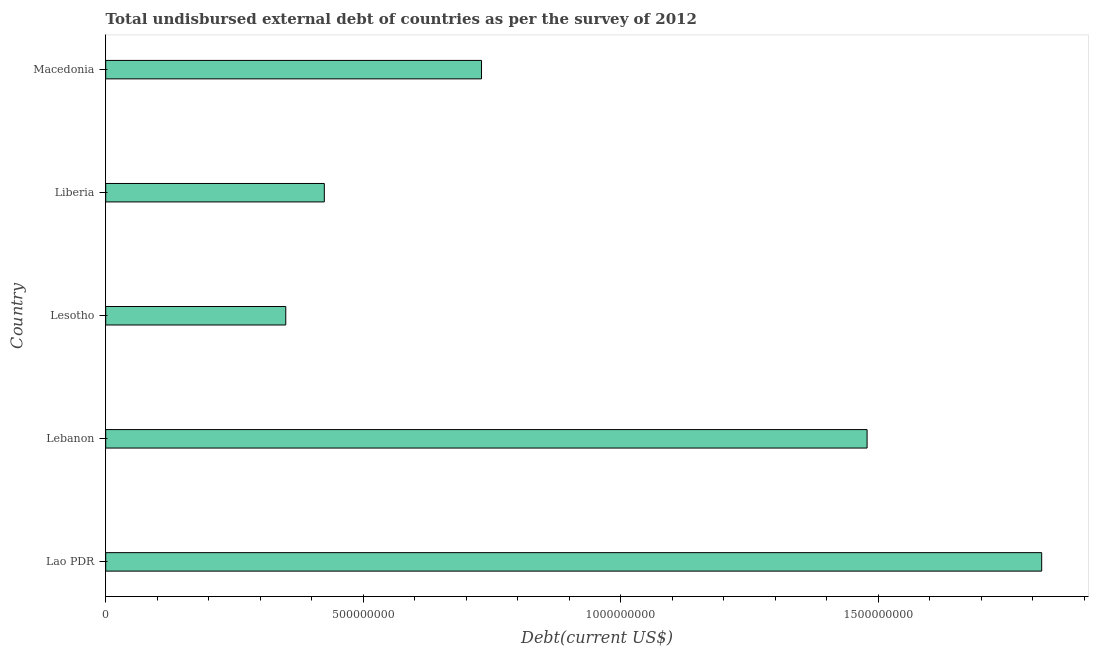Does the graph contain any zero values?
Your response must be concise. No. What is the title of the graph?
Make the answer very short. Total undisbursed external debt of countries as per the survey of 2012. What is the label or title of the X-axis?
Give a very brief answer. Debt(current US$). What is the total debt in Macedonia?
Ensure brevity in your answer.  7.30e+08. Across all countries, what is the maximum total debt?
Offer a very short reply. 1.82e+09. Across all countries, what is the minimum total debt?
Keep it short and to the point. 3.50e+08. In which country was the total debt maximum?
Ensure brevity in your answer.  Lao PDR. In which country was the total debt minimum?
Your response must be concise. Lesotho. What is the sum of the total debt?
Offer a very short reply. 4.80e+09. What is the difference between the total debt in Lebanon and Macedonia?
Offer a very short reply. 7.48e+08. What is the average total debt per country?
Ensure brevity in your answer.  9.60e+08. What is the median total debt?
Your answer should be very brief. 7.30e+08. In how many countries, is the total debt greater than 1700000000 US$?
Keep it short and to the point. 1. What is the ratio of the total debt in Lao PDR to that in Liberia?
Your answer should be compact. 4.28. Is the total debt in Lebanon less than that in Liberia?
Keep it short and to the point. No. What is the difference between the highest and the second highest total debt?
Offer a terse response. 3.39e+08. What is the difference between the highest and the lowest total debt?
Give a very brief answer. 1.47e+09. In how many countries, is the total debt greater than the average total debt taken over all countries?
Keep it short and to the point. 2. How many bars are there?
Ensure brevity in your answer.  5. Are all the bars in the graph horizontal?
Provide a short and direct response. Yes. Are the values on the major ticks of X-axis written in scientific E-notation?
Your answer should be very brief. No. What is the Debt(current US$) of Lao PDR?
Your answer should be compact. 1.82e+09. What is the Debt(current US$) in Lebanon?
Your response must be concise. 1.48e+09. What is the Debt(current US$) of Lesotho?
Ensure brevity in your answer.  3.50e+08. What is the Debt(current US$) of Liberia?
Offer a terse response. 4.24e+08. What is the Debt(current US$) in Macedonia?
Give a very brief answer. 7.30e+08. What is the difference between the Debt(current US$) in Lao PDR and Lebanon?
Ensure brevity in your answer.  3.39e+08. What is the difference between the Debt(current US$) in Lao PDR and Lesotho?
Your answer should be compact. 1.47e+09. What is the difference between the Debt(current US$) in Lao PDR and Liberia?
Your response must be concise. 1.39e+09. What is the difference between the Debt(current US$) in Lao PDR and Macedonia?
Offer a terse response. 1.09e+09. What is the difference between the Debt(current US$) in Lebanon and Lesotho?
Offer a very short reply. 1.13e+09. What is the difference between the Debt(current US$) in Lebanon and Liberia?
Ensure brevity in your answer.  1.05e+09. What is the difference between the Debt(current US$) in Lebanon and Macedonia?
Provide a succinct answer. 7.48e+08. What is the difference between the Debt(current US$) in Lesotho and Liberia?
Provide a succinct answer. -7.48e+07. What is the difference between the Debt(current US$) in Lesotho and Macedonia?
Provide a short and direct response. -3.80e+08. What is the difference between the Debt(current US$) in Liberia and Macedonia?
Your answer should be very brief. -3.05e+08. What is the ratio of the Debt(current US$) in Lao PDR to that in Lebanon?
Offer a very short reply. 1.23. What is the ratio of the Debt(current US$) in Lao PDR to that in Lesotho?
Offer a very short reply. 5.2. What is the ratio of the Debt(current US$) in Lao PDR to that in Liberia?
Give a very brief answer. 4.28. What is the ratio of the Debt(current US$) in Lao PDR to that in Macedonia?
Provide a succinct answer. 2.49. What is the ratio of the Debt(current US$) in Lebanon to that in Lesotho?
Give a very brief answer. 4.23. What is the ratio of the Debt(current US$) in Lebanon to that in Liberia?
Give a very brief answer. 3.48. What is the ratio of the Debt(current US$) in Lebanon to that in Macedonia?
Your response must be concise. 2.03. What is the ratio of the Debt(current US$) in Lesotho to that in Liberia?
Ensure brevity in your answer.  0.82. What is the ratio of the Debt(current US$) in Lesotho to that in Macedonia?
Provide a succinct answer. 0.48. What is the ratio of the Debt(current US$) in Liberia to that in Macedonia?
Your answer should be compact. 0.58. 